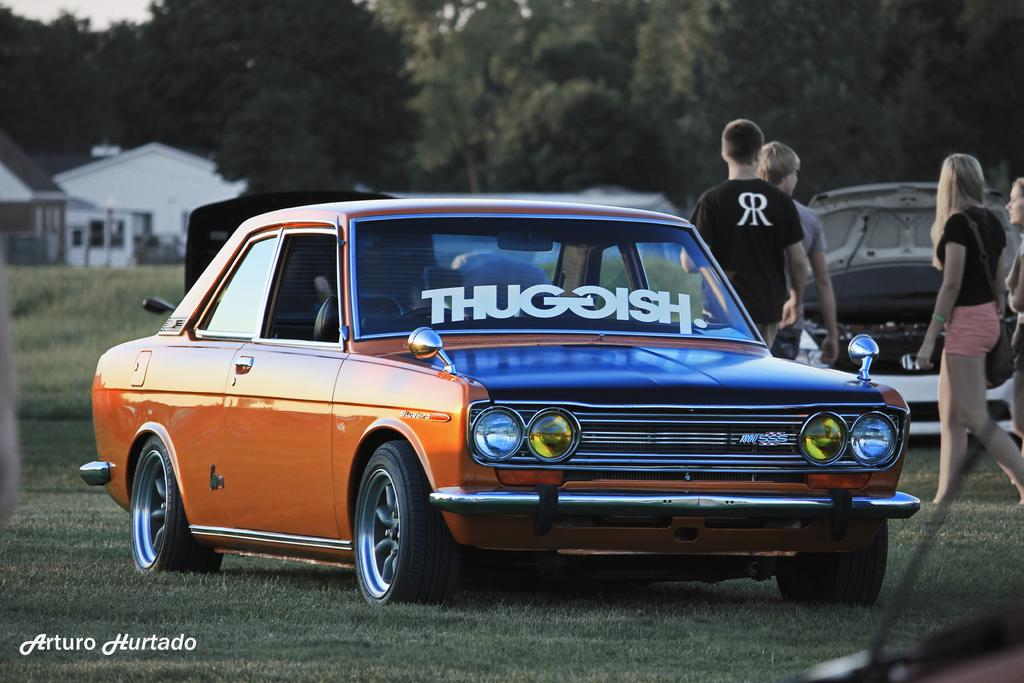What types of objects can be seen in the image? There are vehicles in the image. What are the people in the image doing? The people are on the grass in the image. What can be seen in the distance in the image? There are houses and trees in the background of the image. What part of the natural environment is visible in the image? The sky is visible in the background of the image. What direction are the birds flying in the image? There are no birds present in the image, so it is not possible to determine the direction they might be flying. 